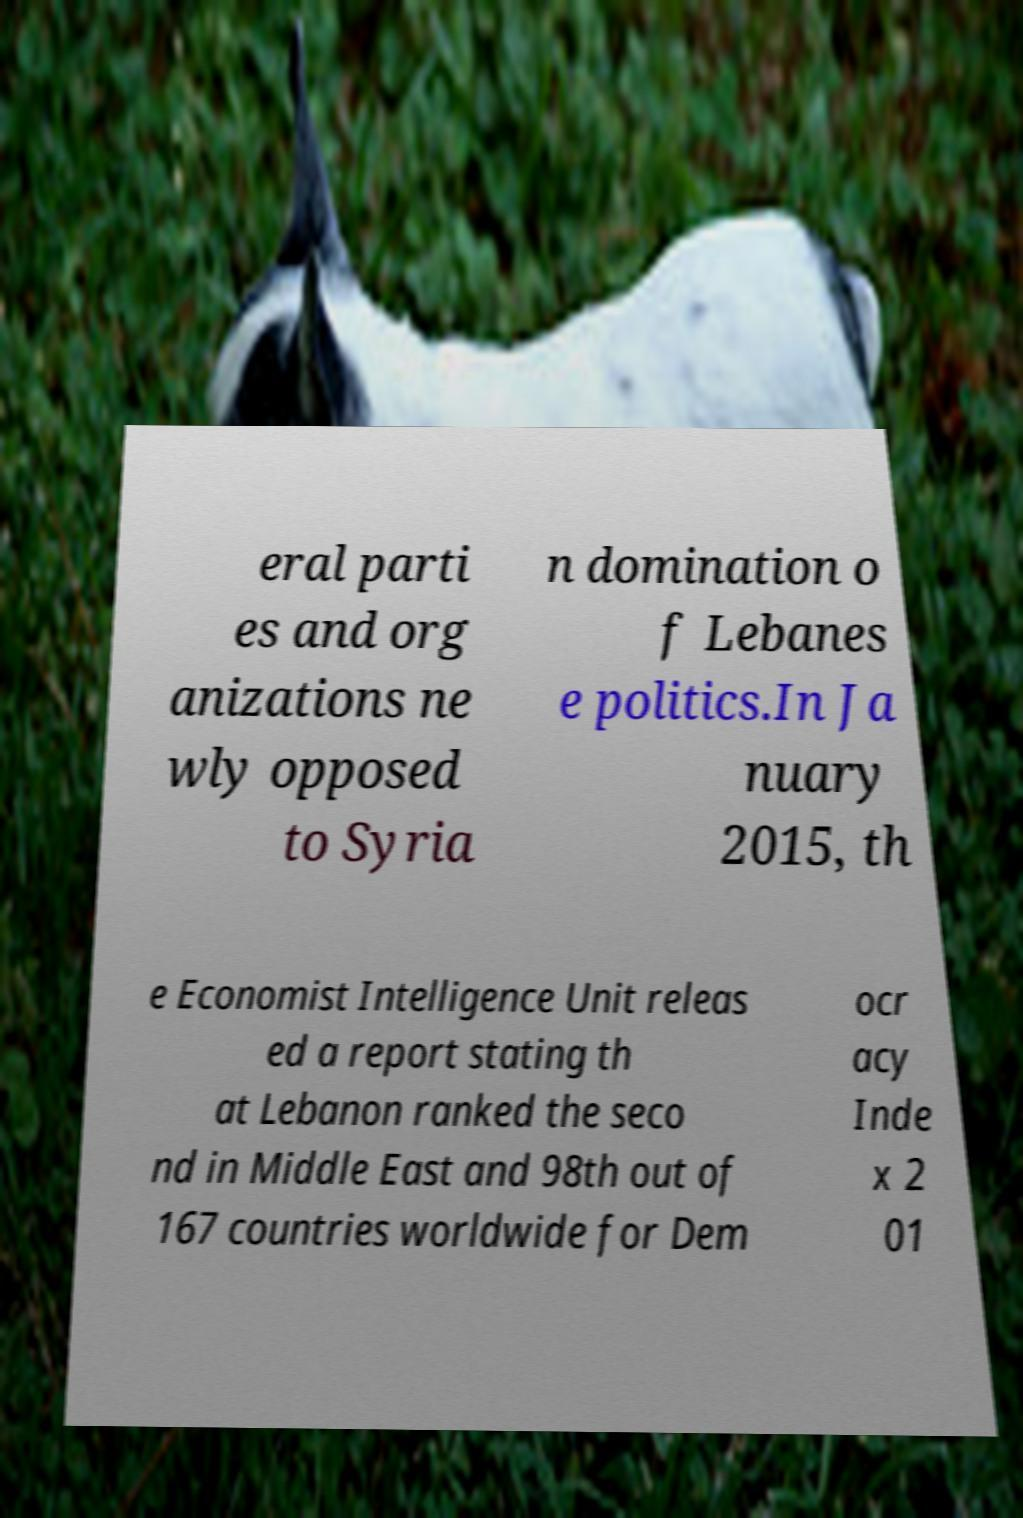For documentation purposes, I need the text within this image transcribed. Could you provide that? eral parti es and org anizations ne wly opposed to Syria n domination o f Lebanes e politics.In Ja nuary 2015, th e Economist Intelligence Unit releas ed a report stating th at Lebanon ranked the seco nd in Middle East and 98th out of 167 countries worldwide for Dem ocr acy Inde x 2 01 